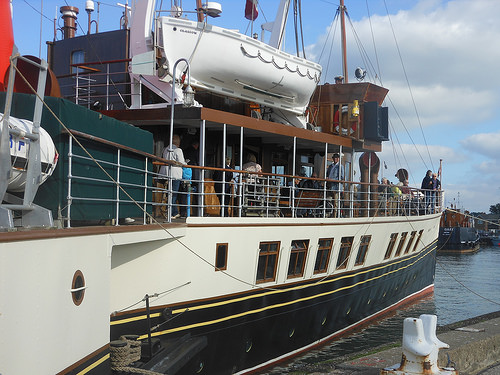<image>
Is the liferaft above the boat? Yes. The liferaft is positioned above the boat in the vertical space, higher up in the scene. 